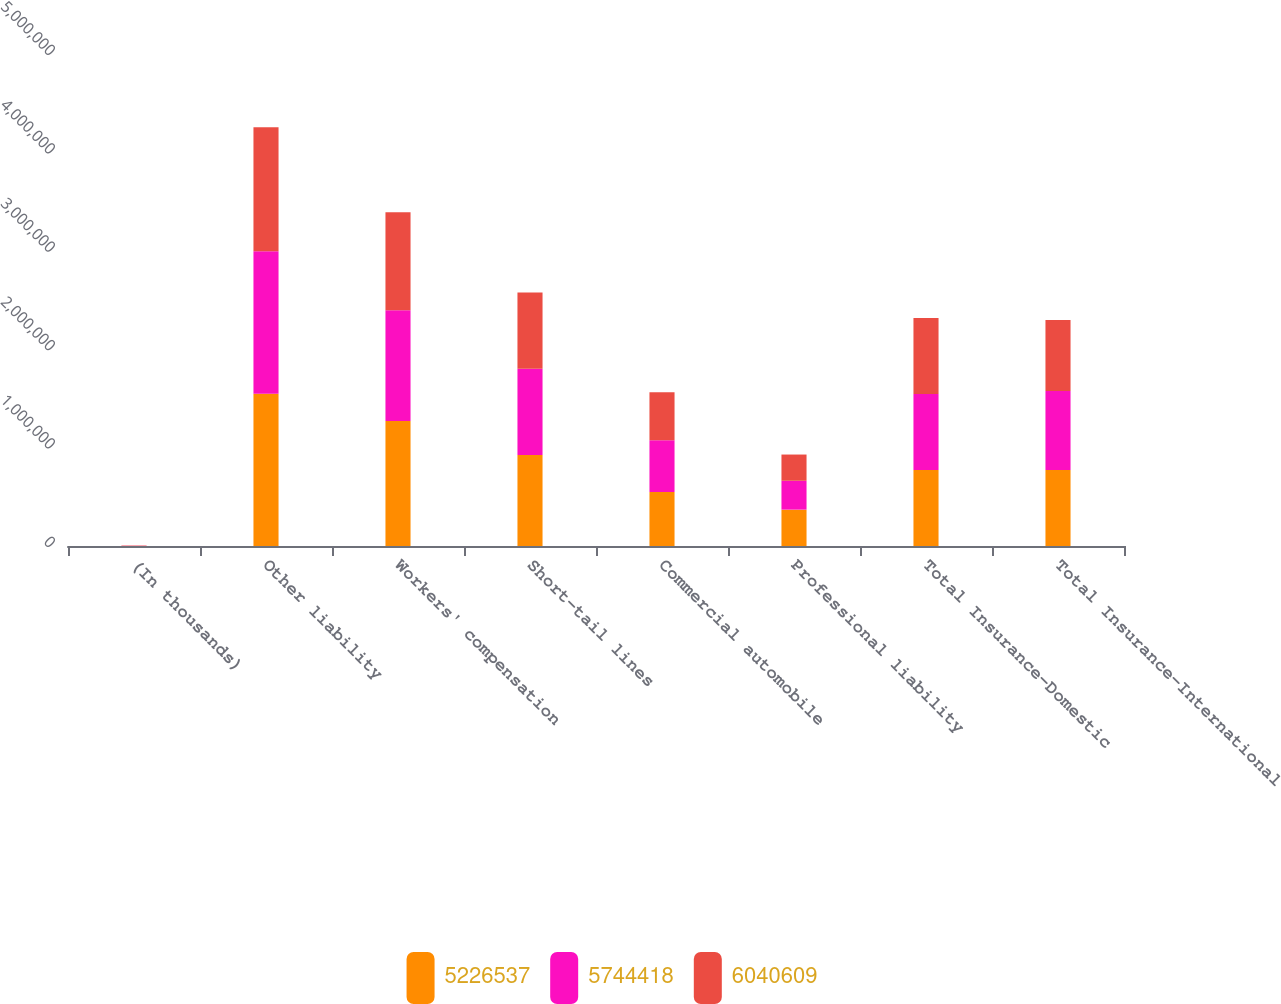<chart> <loc_0><loc_0><loc_500><loc_500><stacked_bar_chart><ecel><fcel>(In thousands)<fcel>Other liability<fcel>Workers' compensation<fcel>Short-tail lines<fcel>Commercial automobile<fcel>Professional liability<fcel>Total Insurance-Domestic<fcel>Total Insurance-International<nl><fcel>5.22654e+06<fcel>2015<fcel>1.54616e+06<fcel>1.26978e+06<fcel>925468<fcel>548450<fcel>369499<fcel>772141<fcel>772141<nl><fcel>5.74442e+06<fcel>2014<fcel>1.44942e+06<fcel>1.1267e+06<fcel>875898<fcel>526344<fcel>293562<fcel>772141<fcel>802375<nl><fcel>6.04061e+06<fcel>2013<fcel>1.25938e+06<fcel>995047<fcel>774809<fcel>486759<fcel>266425<fcel>772141<fcel>723151<nl></chart> 